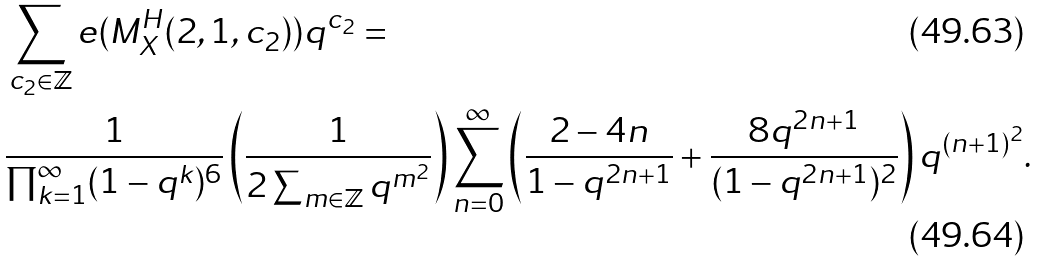<formula> <loc_0><loc_0><loc_500><loc_500>& \sum _ { c _ { 2 } \in \mathbb { Z } } e ( M _ { X } ^ { H } ( 2 , 1 , c _ { 2 } ) ) q ^ { c _ { 2 } } = \\ & \frac { 1 } { \prod _ { k = 1 } ^ { \infty } ( 1 - q ^ { k } ) ^ { 6 } } \left ( \frac { 1 } { 2 \sum _ { m \in \mathbb { Z } } q ^ { m ^ { 2 } } } \right ) \sum _ { n = 0 } ^ { \infty } \left ( \frac { 2 - 4 n } { 1 - q ^ { 2 n + 1 } } + \frac { 8 q ^ { 2 n + 1 } } { ( 1 - q ^ { 2 n + 1 } ) ^ { 2 } } \right ) q ^ { ( n + 1 ) ^ { 2 } } .</formula> 